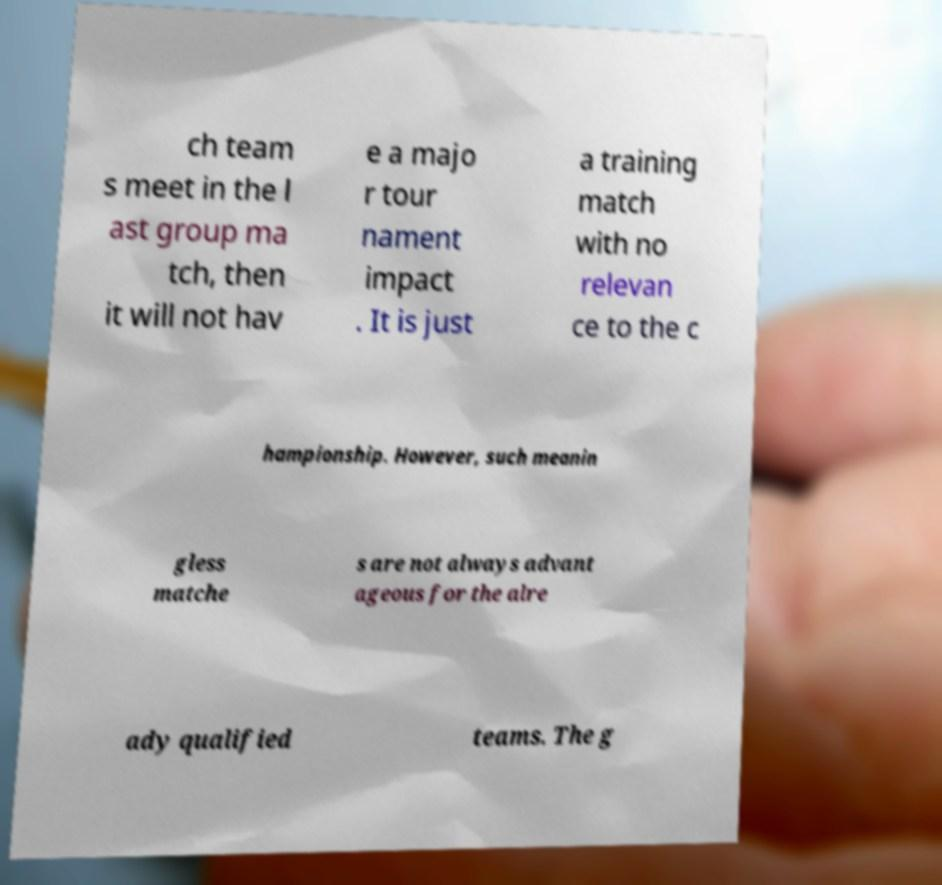Please read and relay the text visible in this image. What does it say? ch team s meet in the l ast group ma tch, then it will not hav e a majo r tour nament impact . It is just a training match with no relevan ce to the c hampionship. However, such meanin gless matche s are not always advant ageous for the alre ady qualified teams. The g 